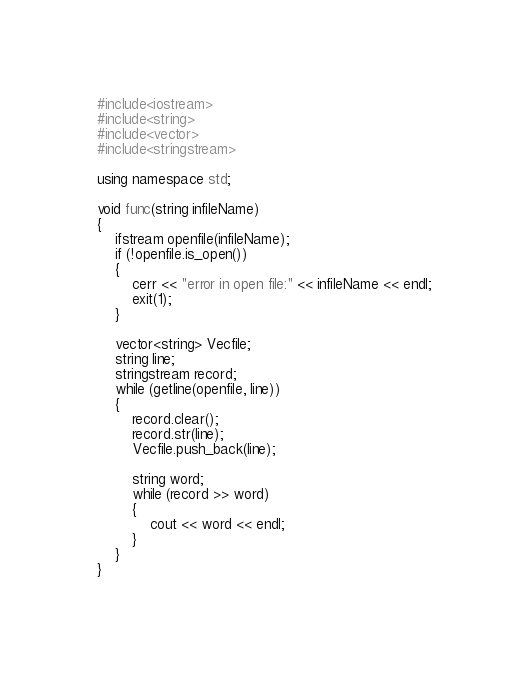Convert code to text. <code><loc_0><loc_0><loc_500><loc_500><_C++_>#include<iostream>
#include<string>
#include<vector>
#include<stringstream>

using namespace std;

void func(string infileName)
{
	ifstream openfile(infileName);
	if (!openfile.is_open())
	{
		cerr << "error in open file:" << infileName << endl;
		exit(1);
	}

	vector<string> Vecfile;
	string line;
	stringstream record;
	while (getline(openfile, line))
	{
		record.clear();
		record.str(line);
		Vecfile.push_back(line);

		string word;
		while (record >> word)
		{
			cout << word << endl;
		}
	}
}</code> 